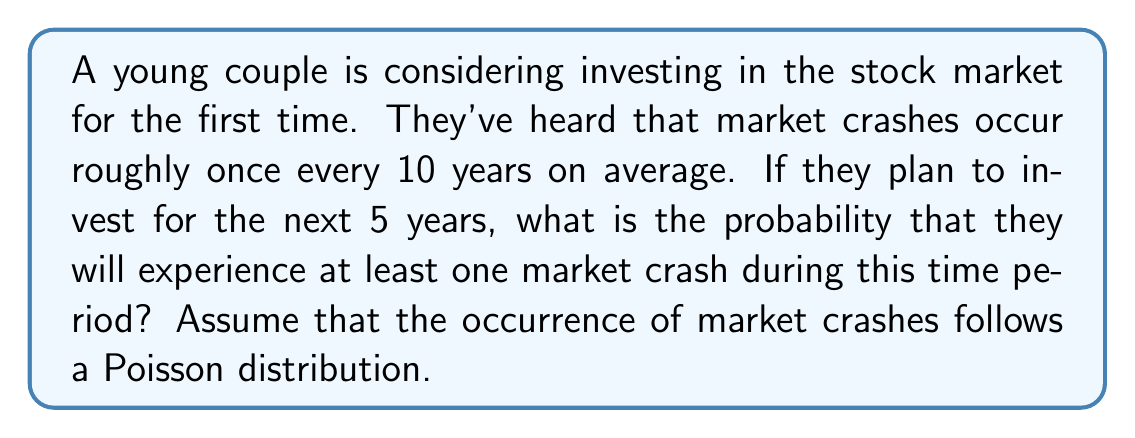Can you solve this math problem? To solve this problem, we'll use the Poisson distribution, which is appropriate for modeling rare events over a fixed interval of time. Let's break it down step-by-step:

1) First, we need to calculate the rate parameter λ (lambda) for our 5-year period:
   
   If crashes occur once every 10 years on average, then in 5 years:
   $$ \lambda = \frac{5 \text{ years}}{10 \text{ years/crash}} = 0.5 \text{ crashes} $$

2) The probability of experiencing at least one crash is the complement of experiencing no crashes:
   
   $$ P(\text{at least one crash}) = 1 - P(\text{no crashes}) $$

3) The probability of experiencing exactly k events in a Poisson distribution is given by:
   
   $$ P(X = k) = \frac{e^{-\lambda} \lambda^k}{k!} $$

4) For no crashes (k = 0):
   
   $$ P(X = 0) = \frac{e^{-0.5} (0.5)^0}{0!} = e^{-0.5} $$

5) Therefore, the probability of at least one crash is:
   
   $$ P(\text{at least one crash}) = 1 - e^{-0.5} $$

6) Calculating this:
   $$ 1 - e^{-0.5} \approx 1 - 0.6065 \approx 0.3935 $$

Thus, there is approximately a 39.35% chance of experiencing at least one market crash during the 5-year investment period.
Answer: The probability of experiencing at least one market crash during the 5-year investment period is approximately 0.3935 or 39.35%. 